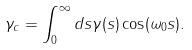<formula> <loc_0><loc_0><loc_500><loc_500>\gamma _ { c } = \int _ { 0 } ^ { \infty } d s \gamma ( s ) \cos ( \omega _ { 0 } s ) .</formula> 